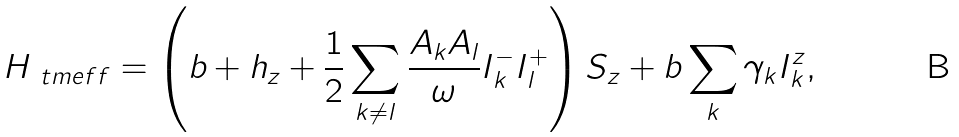Convert formula to latex. <formula><loc_0><loc_0><loc_500><loc_500>H _ { \ t m { e f f } } = \left ( b + h _ { z } + \frac { 1 } { 2 } \sum _ { k \neq l } \frac { A _ { k } A _ { l } } { \omega } I _ { k } ^ { - } I _ { l } ^ { + } \right ) S _ { z } + b \sum _ { k } \gamma _ { k } I _ { k } ^ { z } ,</formula> 